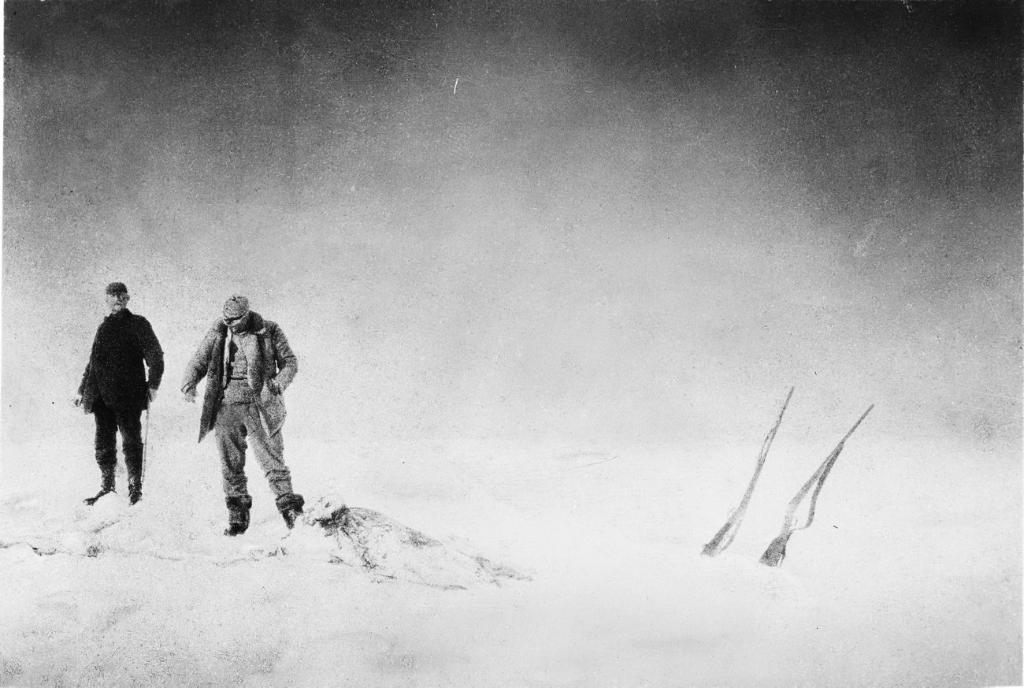How many people are in the image? There are two persons in the image. What is the setting of the image? The persons are standing in the snow. Can you describe any objects in the image? There are two objects in the left corner of the image. What type of animals can be seen in the zoo in the image? There is no zoo present in the image; it features two persons standing in the snow. 